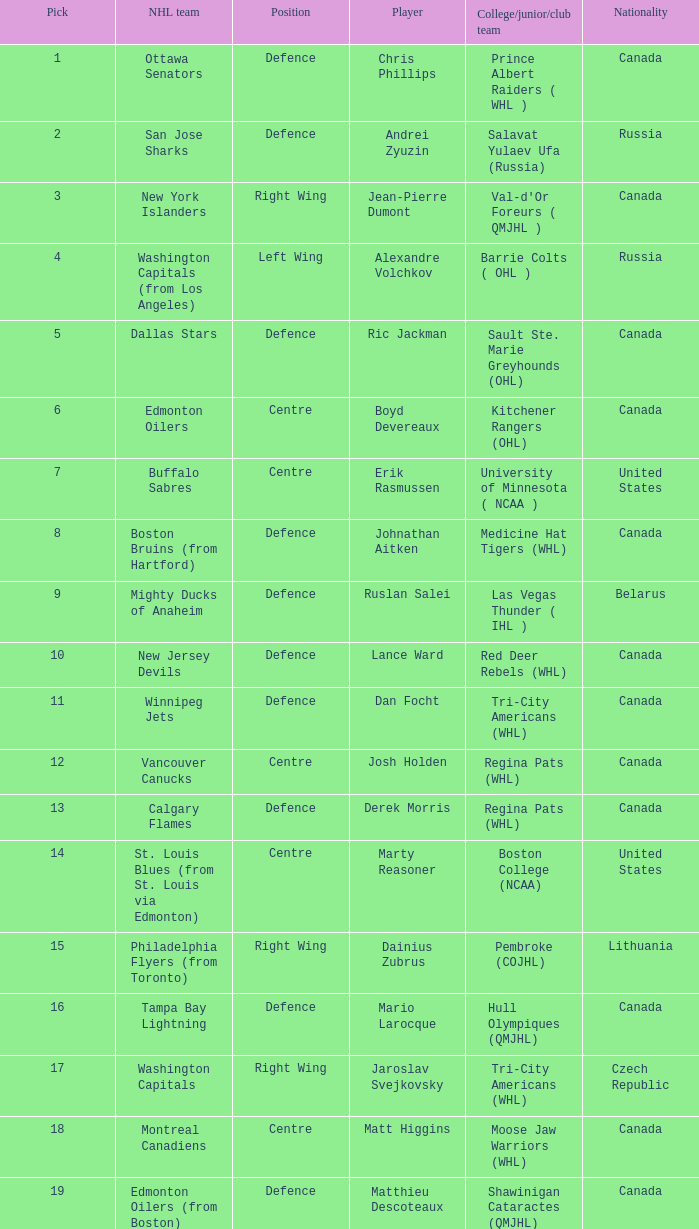How many positions does the draft pick whose nationality is Czech Republic play? 1.0. 